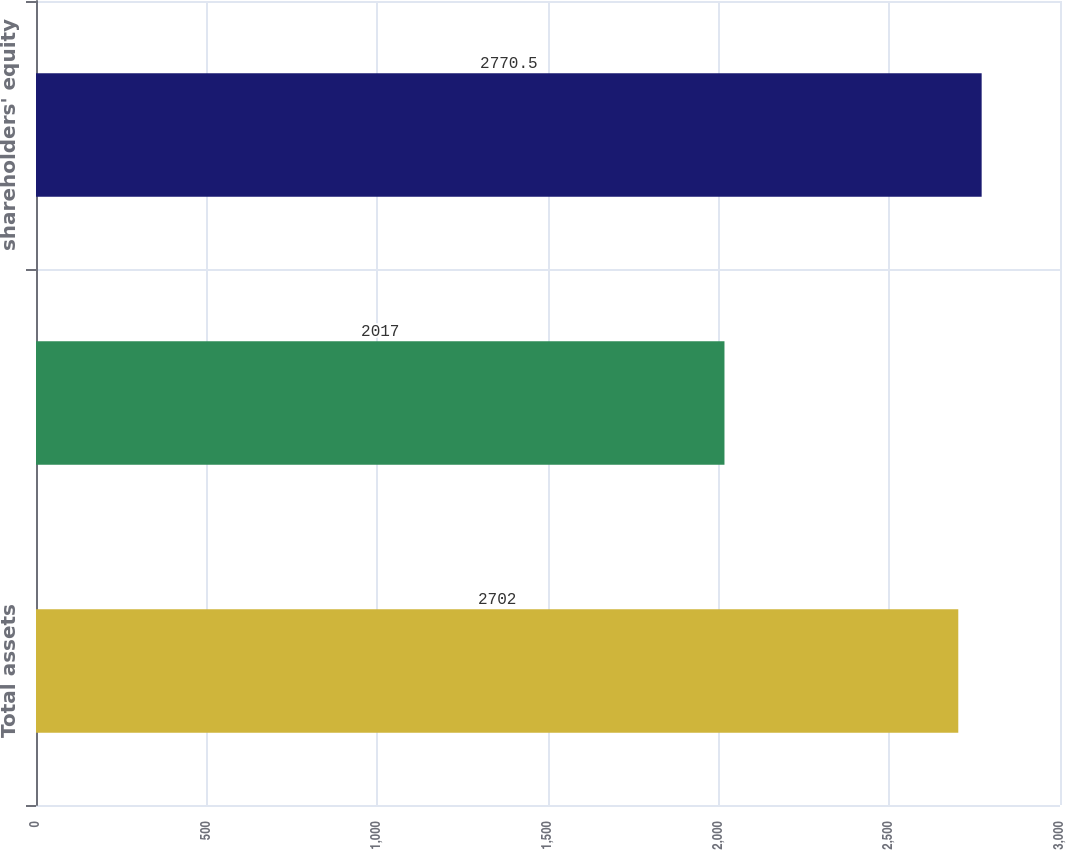<chart> <loc_0><loc_0><loc_500><loc_500><bar_chart><fcel>Total assets<fcel>Total liabilities<fcel>shareholders' equity<nl><fcel>2702<fcel>2017<fcel>2770.5<nl></chart> 